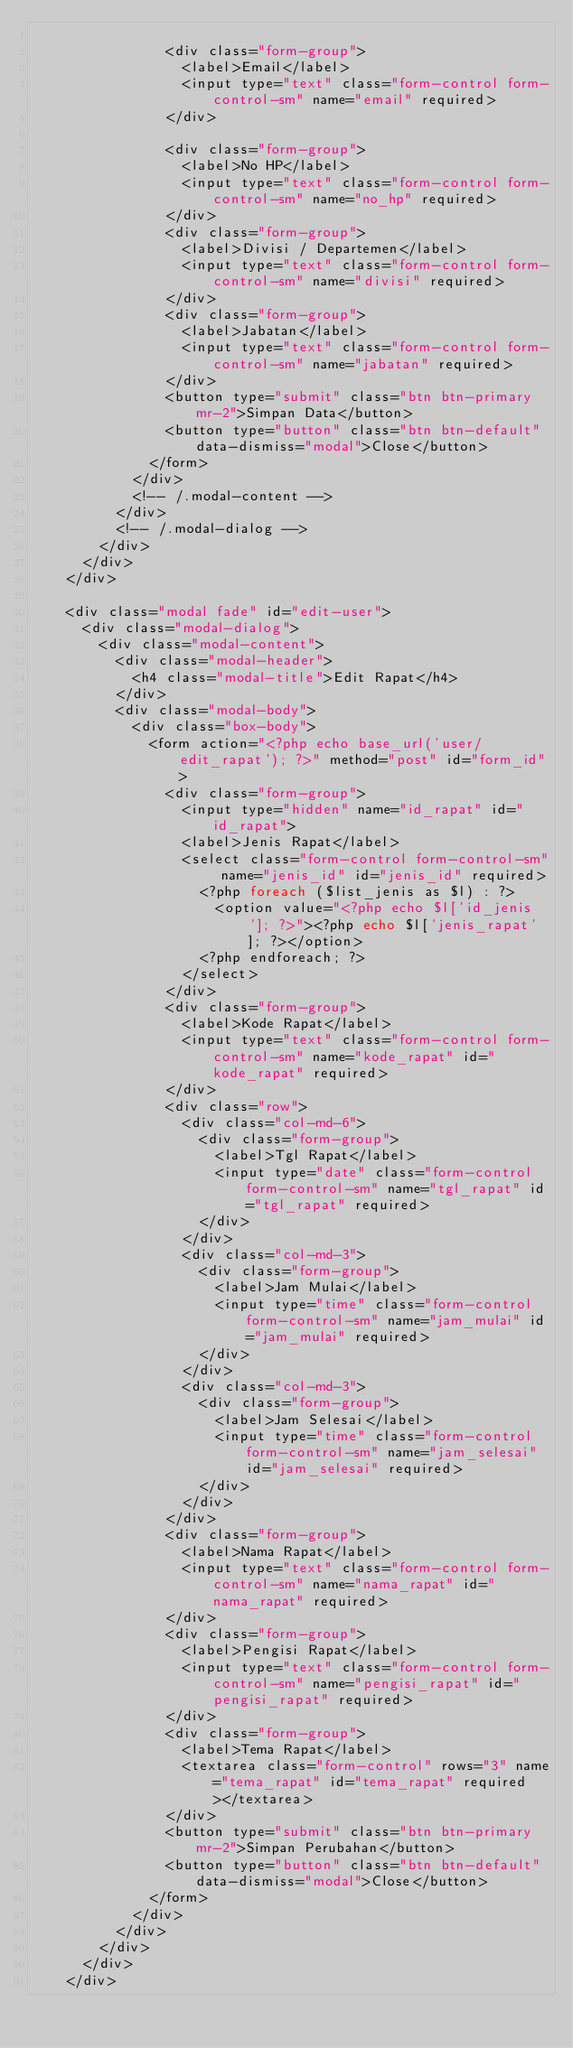Convert code to text. <code><loc_0><loc_0><loc_500><loc_500><_PHP_>
	  						<div class="form-group">
	  							<label>Email</label>
	  							<input type="text" class="form-control form-control-sm" name="email" required>
	  						</div>

	  						<div class="form-group">
	  							<label>No HP</label>
	  							<input type="text" class="form-control form-control-sm" name="no_hp" required>
	  						</div>
	  						<div class="form-group">
	  							<label>Divisi / Departemen</label>
	  							<input type="text" class="form-control form-control-sm" name="divisi" required>
	  						</div>
	  						<div class="form-group">
	  							<label>Jabatan</label>
	  							<input type="text" class="form-control form-control-sm" name="jabatan" required>
	  						</div>
	  						<button type="submit" class="btn btn-primary mr-2">Simpan Data</button>
	  						<button type="button" class="btn btn-default" data-dismiss="modal">Close</button>
	  					</form>
	  				</div>
	  				<!-- /.modal-content -->
	  			</div>
	  			<!-- /.modal-dialog -->
	  		</div>
	  	</div>
	  </div>

	  <div class="modal fade" id="edit-user">
	  	<div class="modal-dialog">
	  		<div class="modal-content">
	  			<div class="modal-header">
	  				<h4 class="modal-title">Edit Rapat</h4>
	  			</div>
	  			<div class="modal-body">
	  				<div class="box-body">
	  					<form action="<?php echo base_url('user/edit_rapat'); ?>" method="post" id="form_id">
	  						<div class="form-group">
	  							<input type="hidden" name="id_rapat" id="id_rapat">
	  							<label>Jenis Rapat</label>
	  							<select class="form-control form-control-sm" name="jenis_id" id="jenis_id" required>
	  								<?php foreach ($list_jenis as $l) : ?>
	  									<option value="<?php echo $l['id_jenis']; ?>"><?php echo $l['jenis_rapat']; ?></option>
	  								<?php endforeach; ?>
	  							</select>
	  						</div>
	  						<div class="form-group">
	  							<label>Kode Rapat</label>
	  							<input type="text" class="form-control form-control-sm" name="kode_rapat" id="kode_rapat" required>
	  						</div>
	  						<div class="row">
	  							<div class="col-md-6">
	  								<div class="form-group">
	  									<label>Tgl Rapat</label>
	  									<input type="date" class="form-control form-control-sm" name="tgl_rapat" id="tgl_rapat" required>
	  								</div>
	  							</div>
	  							<div class="col-md-3">
	  								<div class="form-group">
	  									<label>Jam Mulai</label>
	  									<input type="time" class="form-control form-control-sm" name="jam_mulai" id="jam_mulai" required>
	  								</div>
	  							</div>
	  							<div class="col-md-3">
	  								<div class="form-group">
	  									<label>Jam Selesai</label>
	  									<input type="time" class="form-control form-control-sm" name="jam_selesai" id="jam_selesai" required>
	  								</div>
	  							</div>
	  						</div>
	  						<div class="form-group">
	  							<label>Nama Rapat</label>
	  							<input type="text" class="form-control form-control-sm" name="nama_rapat" id="nama_rapat" required>
	  						</div>
	  						<div class="form-group">
	  							<label>Pengisi Rapat</label>
	  							<input type="text" class="form-control form-control-sm" name="pengisi_rapat" id="pengisi_rapat" required>
	  						</div>
	  						<div class="form-group">
	  							<label>Tema Rapat</label>
	  							<textarea class="form-control" rows="3" name="tema_rapat" id="tema_rapat" required></textarea>
	  						</div>
	  						<button type="submit" class="btn btn-primary mr-2">Simpan Perubahan</button>
	  						<button type="button" class="btn btn-default" data-dismiss="modal">Close</button>
	  					</form>
	  				</div>
	  			</div>
	  		</div>
	  	</div>
	  </div></code> 